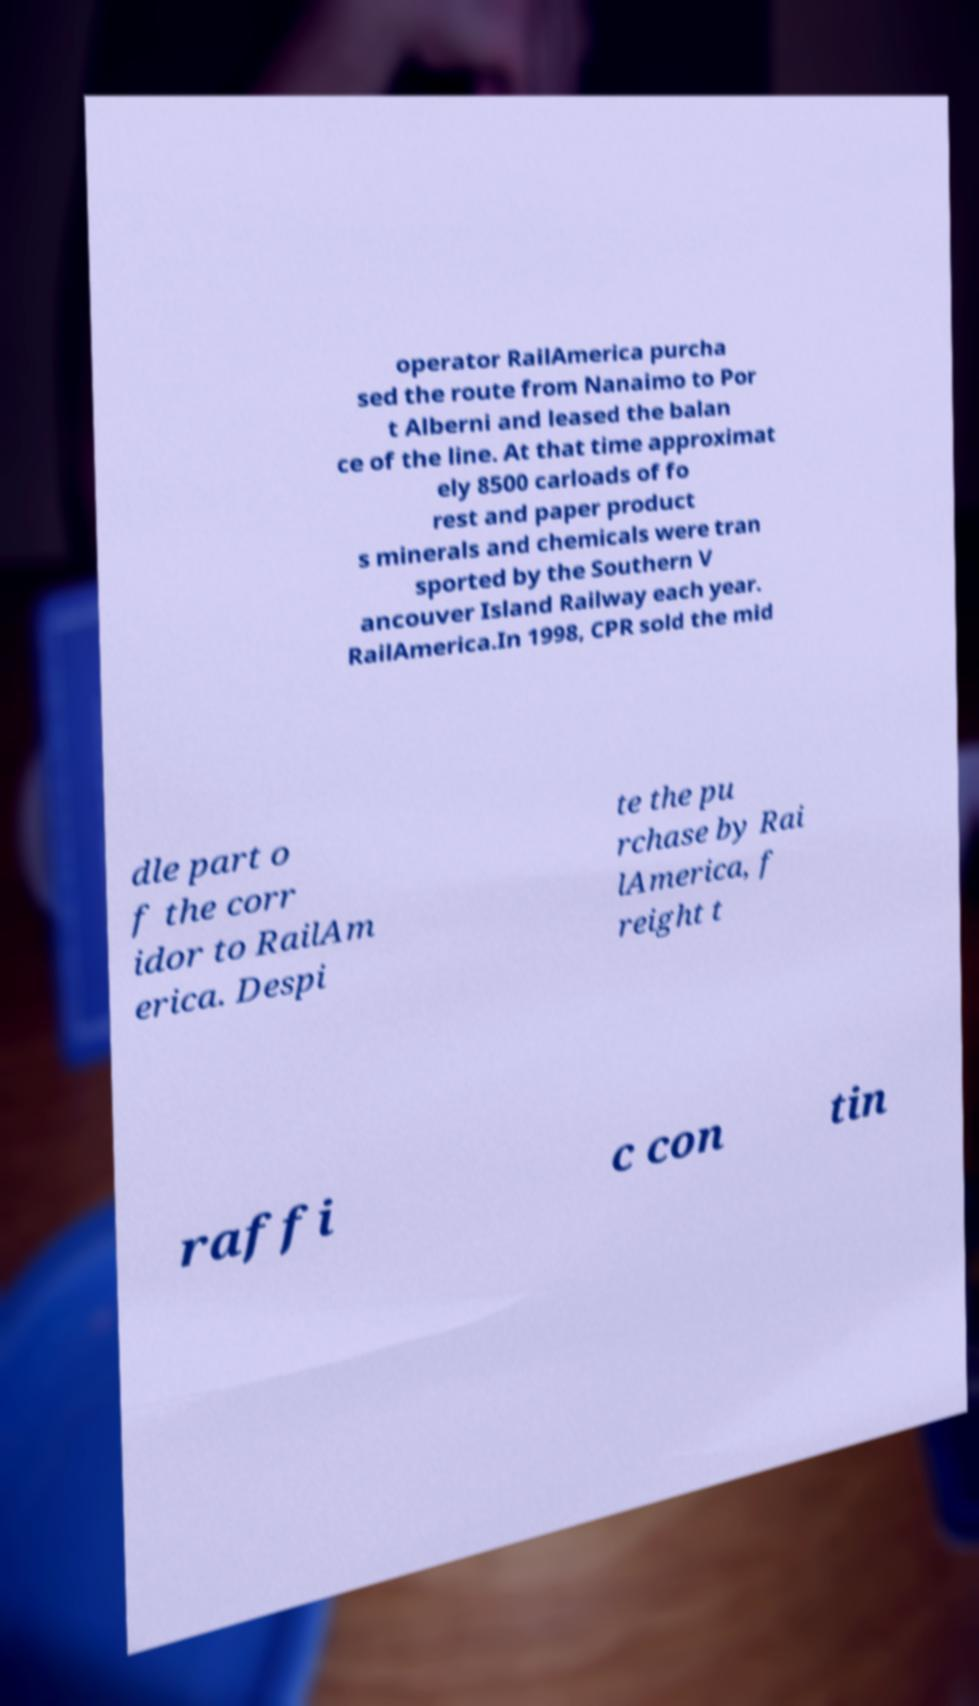Can you read and provide the text displayed in the image?This photo seems to have some interesting text. Can you extract and type it out for me? operator RailAmerica purcha sed the route from Nanaimo to Por t Alberni and leased the balan ce of the line. At that time approximat ely 8500 carloads of fo rest and paper product s minerals and chemicals were tran sported by the Southern V ancouver Island Railway each year. RailAmerica.In 1998, CPR sold the mid dle part o f the corr idor to RailAm erica. Despi te the pu rchase by Rai lAmerica, f reight t raffi c con tin 